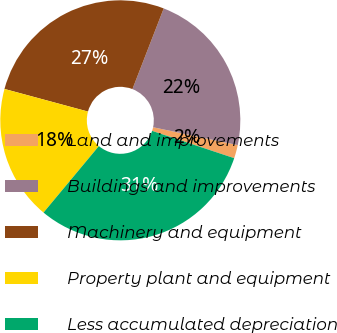Convert chart. <chart><loc_0><loc_0><loc_500><loc_500><pie_chart><fcel>Land and improvements<fcel>Buildings and improvements<fcel>Machinery and equipment<fcel>Property plant and equipment<fcel>Less accumulated depreciation<nl><fcel>1.8%<fcel>22.42%<fcel>26.68%<fcel>18.16%<fcel>30.94%<nl></chart> 